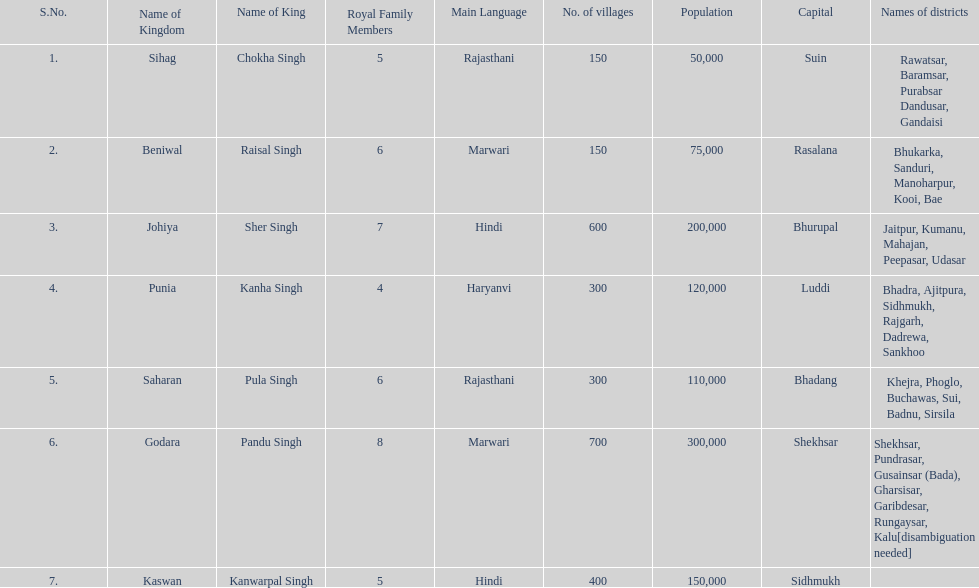How many districts does punia have? 6. 